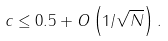<formula> <loc_0><loc_0><loc_500><loc_500>c \leq 0 . 5 + O \left ( 1 / \sqrt { N } \right ) .</formula> 